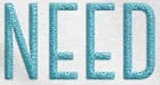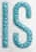What text appears in these images from left to right, separated by a semicolon? NEED; IS 